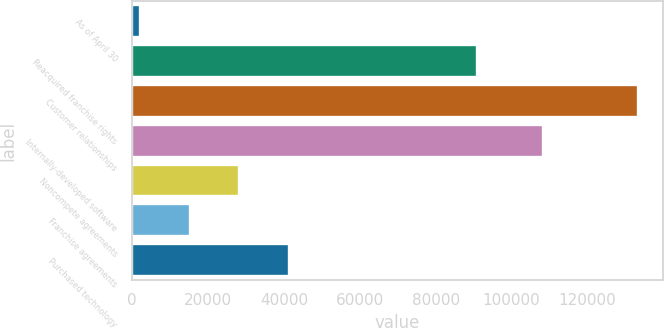Convert chart to OTSL. <chart><loc_0><loc_0><loc_500><loc_500><bar_chart><fcel>As of April 30<fcel>Reacquired franchise rights<fcel>Customer relationships<fcel>Internally-developed software<fcel>Noncompete agreements<fcel>Franchise agreements<fcel>Purchased technology<nl><fcel>2017<fcel>90877<fcel>133207<fcel>108379<fcel>28255<fcel>15136<fcel>41374<nl></chart> 